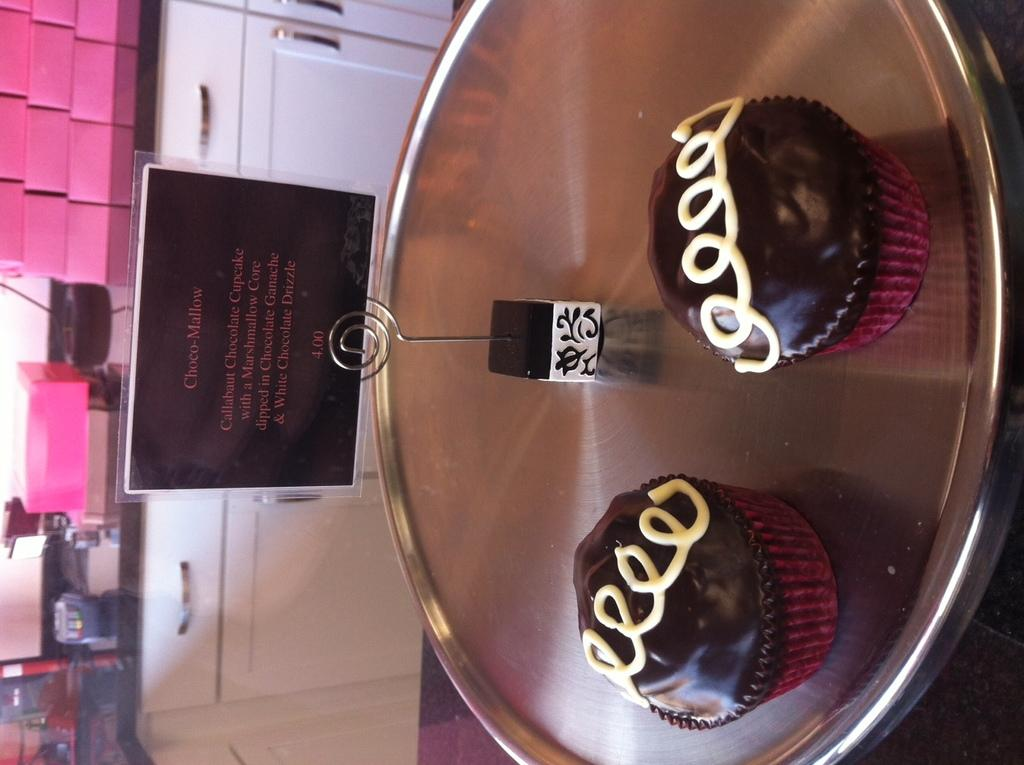<image>
Offer a succinct explanation of the picture presented. Only two Choco-Mallows are left on the silver tray. 